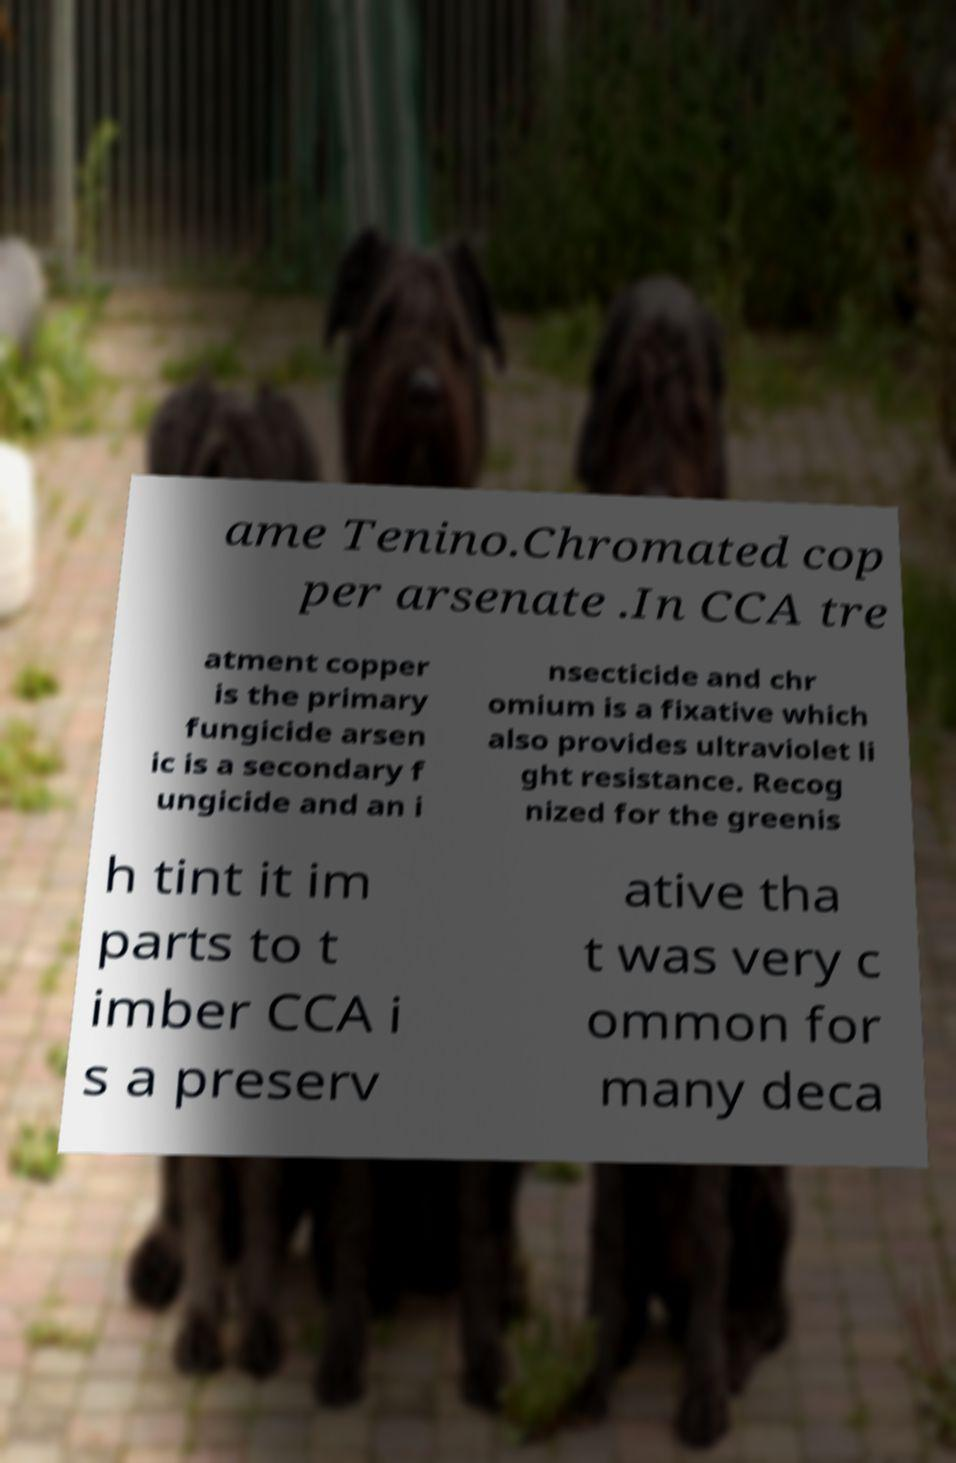There's text embedded in this image that I need extracted. Can you transcribe it verbatim? ame Tenino.Chromated cop per arsenate .In CCA tre atment copper is the primary fungicide arsen ic is a secondary f ungicide and an i nsecticide and chr omium is a fixative which also provides ultraviolet li ght resistance. Recog nized for the greenis h tint it im parts to t imber CCA i s a preserv ative tha t was very c ommon for many deca 